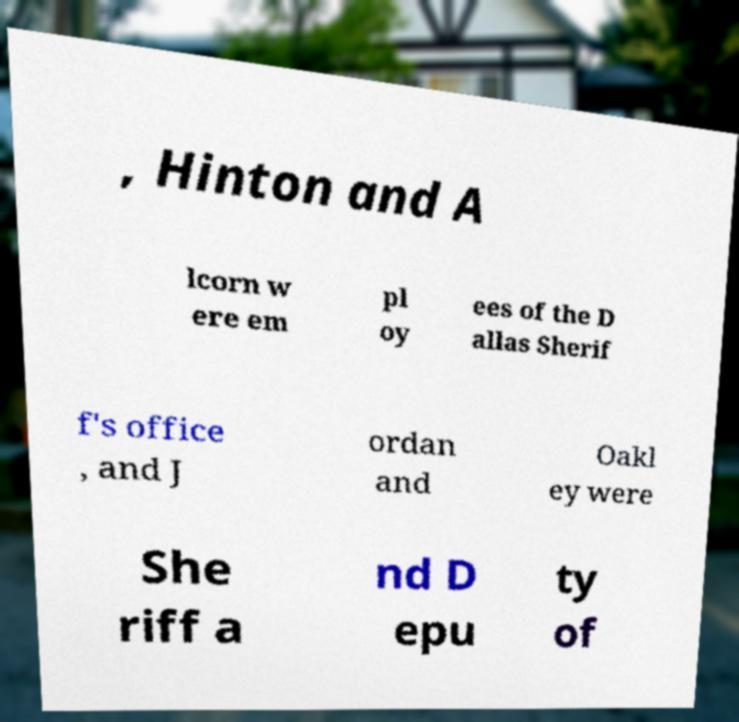Can you read and provide the text displayed in the image?This photo seems to have some interesting text. Can you extract and type it out for me? , Hinton and A lcorn w ere em pl oy ees of the D allas Sherif f's office , and J ordan and Oakl ey were She riff a nd D epu ty of 